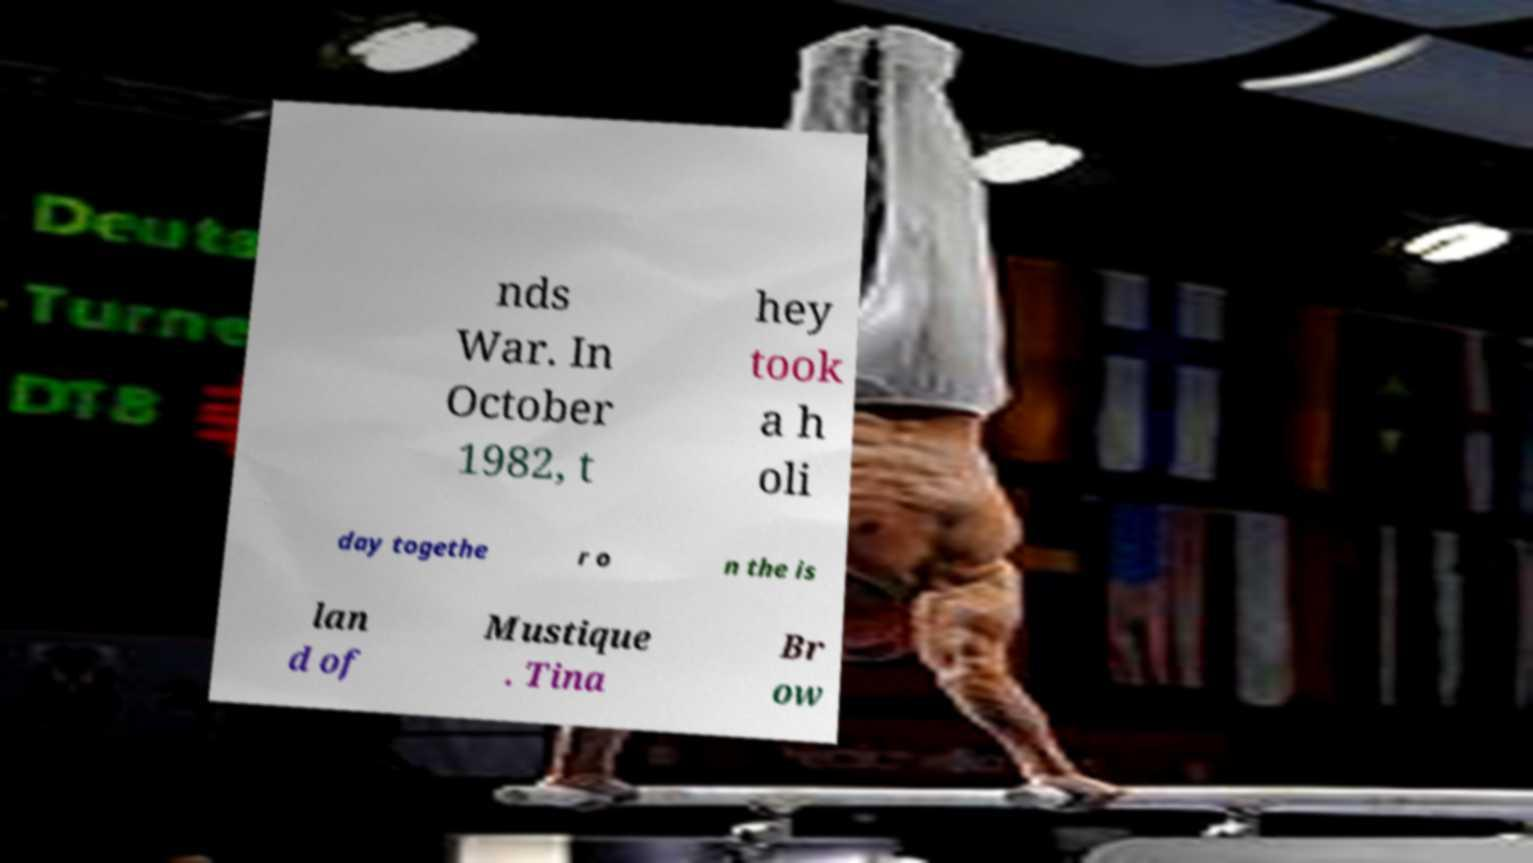Could you assist in decoding the text presented in this image and type it out clearly? nds War. In October 1982, t hey took a h oli day togethe r o n the is lan d of Mustique . Tina Br ow 